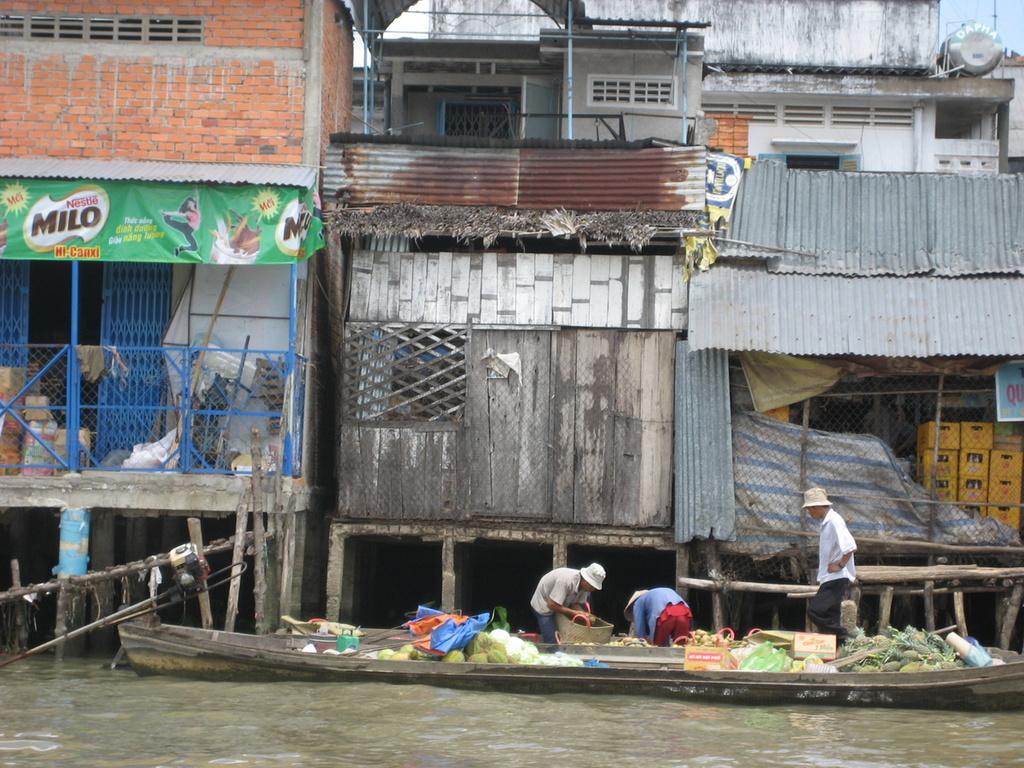Please provide a concise description of this image. In this picture we can see boxes and objects in a boat on the water. There are people and we can see mesh, houses, railing, banner, board, container boxes and objects. In the background of the image we can see the sky. 